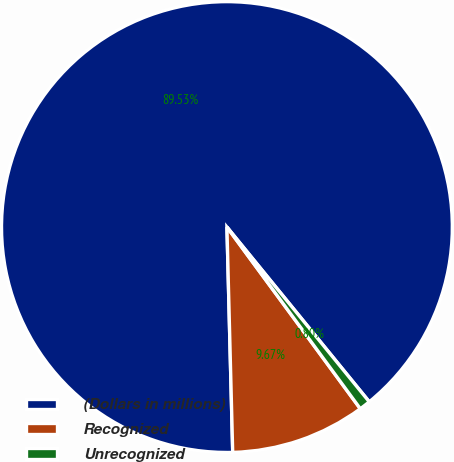<chart> <loc_0><loc_0><loc_500><loc_500><pie_chart><fcel>(Dollars in millions)<fcel>Recognized<fcel>Unrecognized<nl><fcel>89.53%<fcel>9.67%<fcel>0.8%<nl></chart> 